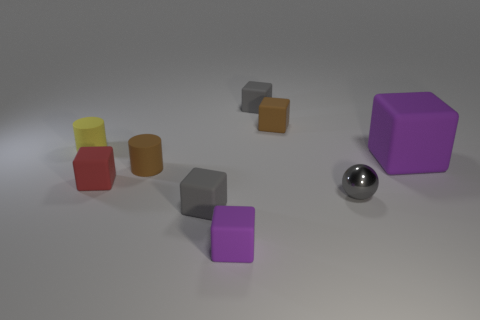Subtract all brown blocks. How many blocks are left? 5 Subtract all small brown blocks. How many blocks are left? 5 Subtract all cyan cubes. Subtract all red cylinders. How many cubes are left? 6 Subtract all blocks. How many objects are left? 3 Add 4 gray metal balls. How many gray metal balls are left? 5 Add 4 cyan cubes. How many cyan cubes exist? 4 Subtract 0 cyan spheres. How many objects are left? 9 Subtract all cyan shiny cylinders. Subtract all gray shiny objects. How many objects are left? 8 